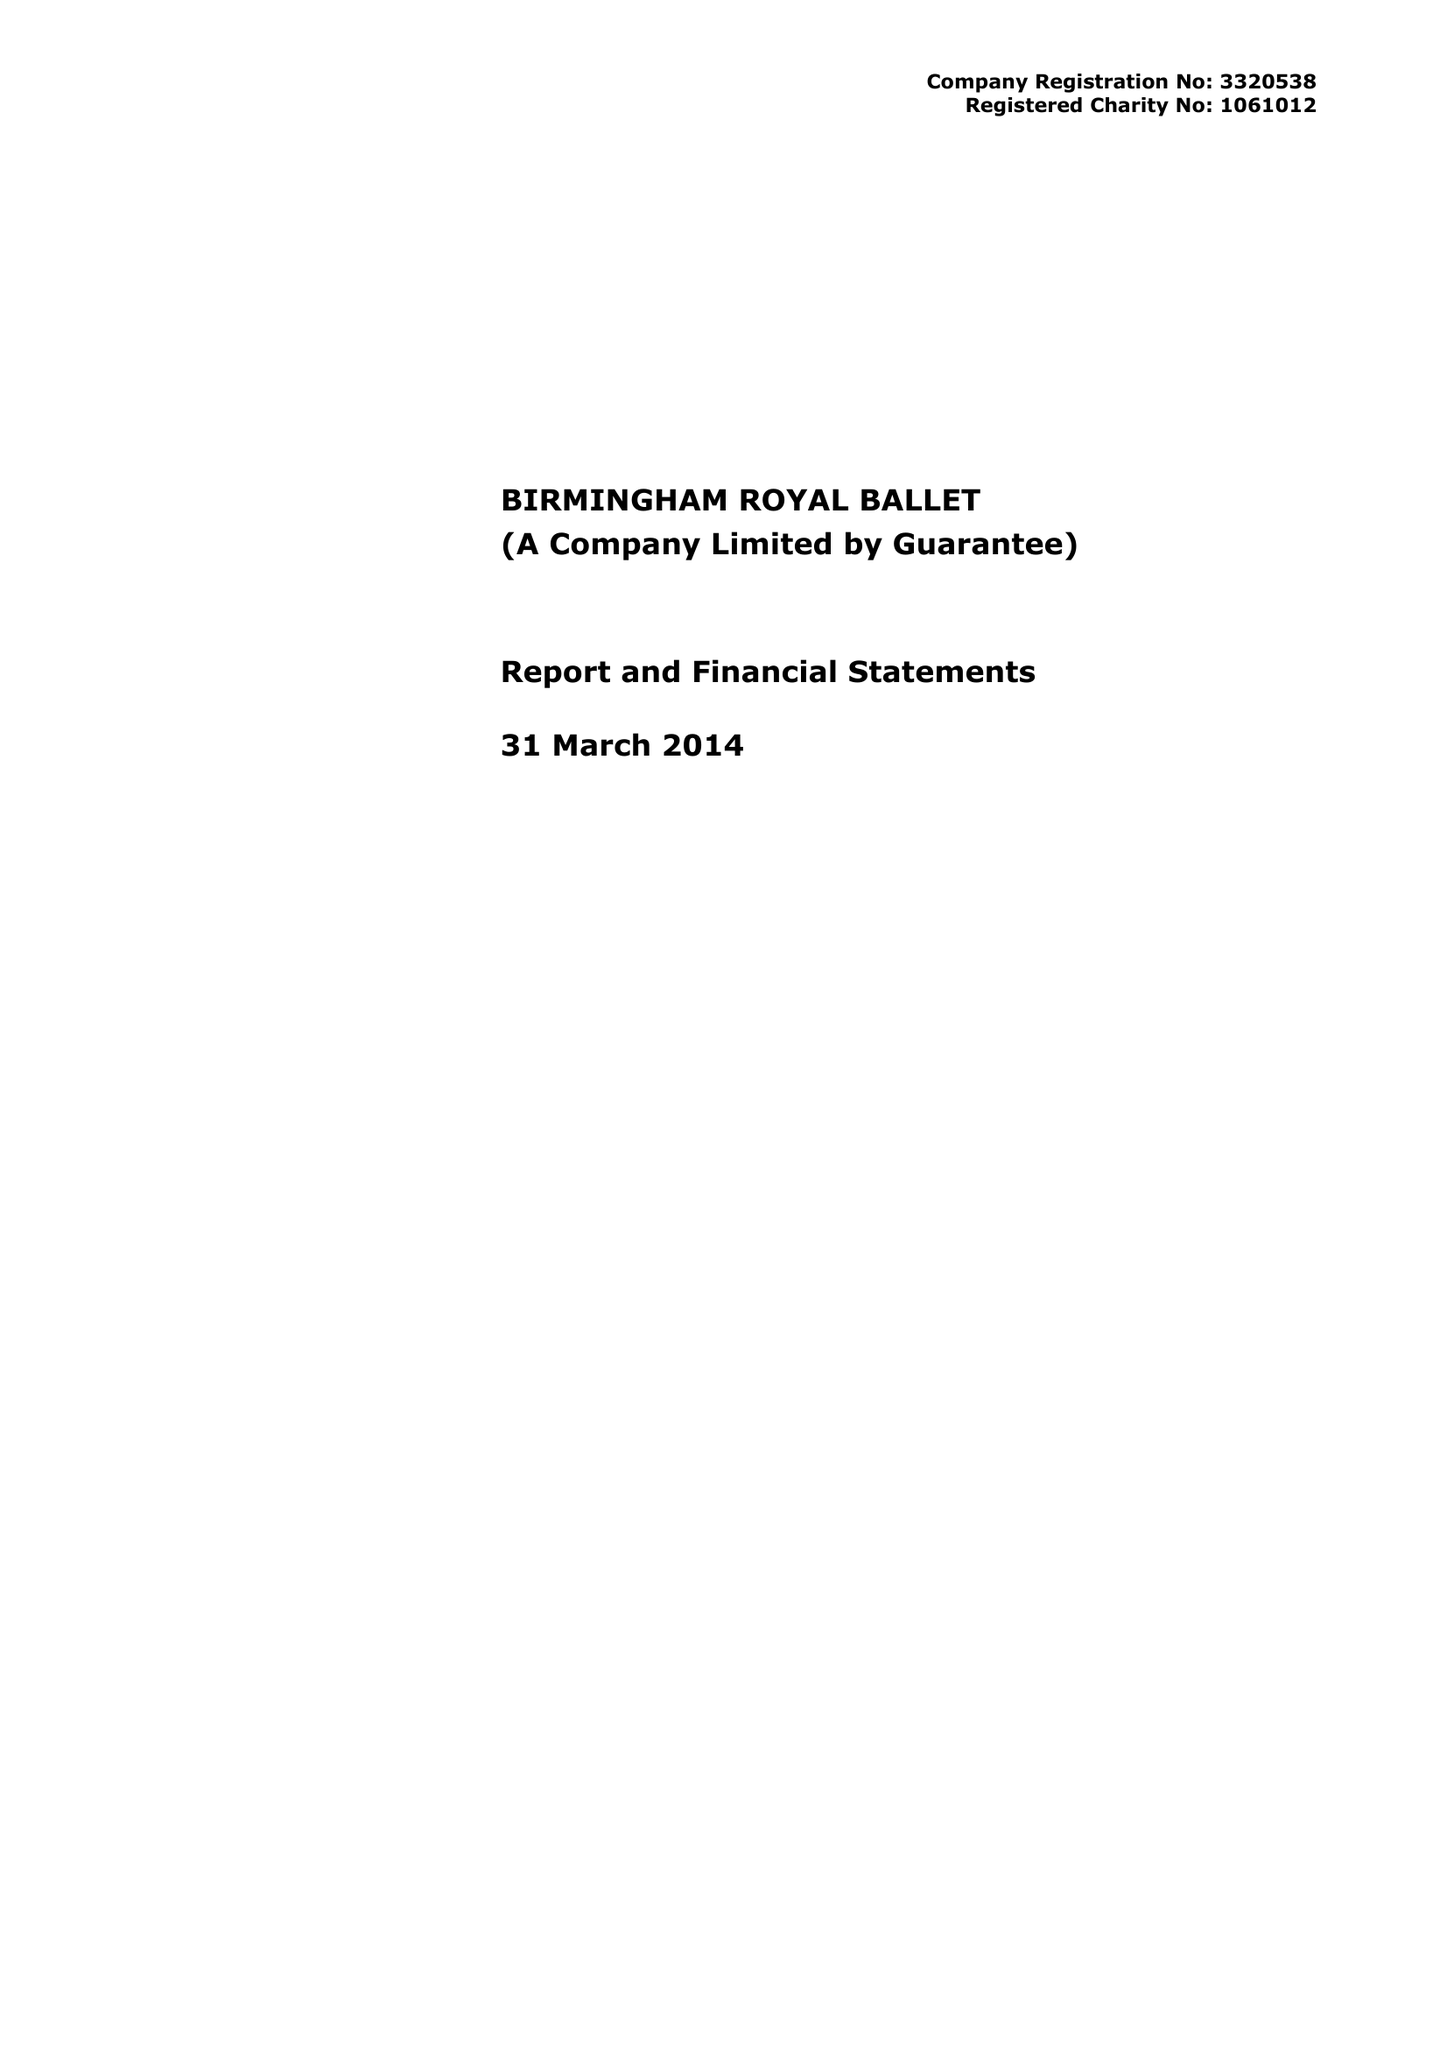What is the value for the charity_number?
Answer the question using a single word or phrase. 1061012 